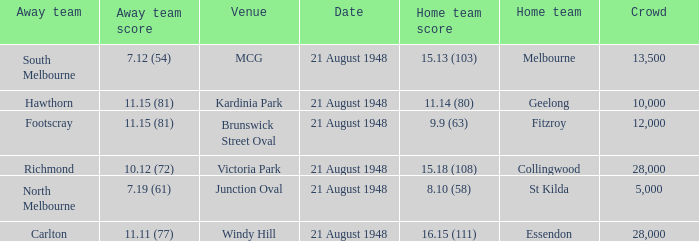Would you be able to parse every entry in this table? {'header': ['Away team', 'Away team score', 'Venue', 'Date', 'Home team score', 'Home team', 'Crowd'], 'rows': [['South Melbourne', '7.12 (54)', 'MCG', '21 August 1948', '15.13 (103)', 'Melbourne', '13,500'], ['Hawthorn', '11.15 (81)', 'Kardinia Park', '21 August 1948', '11.14 (80)', 'Geelong', '10,000'], ['Footscray', '11.15 (81)', 'Brunswick Street Oval', '21 August 1948', '9.9 (63)', 'Fitzroy', '12,000'], ['Richmond', '10.12 (72)', 'Victoria Park', '21 August 1948', '15.18 (108)', 'Collingwood', '28,000'], ['North Melbourne', '7.19 (61)', 'Junction Oval', '21 August 1948', '8.10 (58)', 'St Kilda', '5,000'], ['Carlton', '11.11 (77)', 'Windy Hill', '21 August 1948', '16.15 (111)', 'Essendon', '28,000']]} When the venue is victoria park, what's the largest Crowd that attended? 28000.0. 